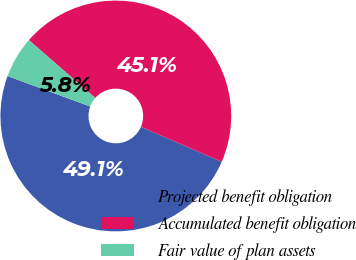Convert chart to OTSL. <chart><loc_0><loc_0><loc_500><loc_500><pie_chart><fcel>Projected benefit obligation<fcel>Accumulated benefit obligation<fcel>Fair value of plan assets<nl><fcel>49.12%<fcel>45.08%<fcel>5.8%<nl></chart> 